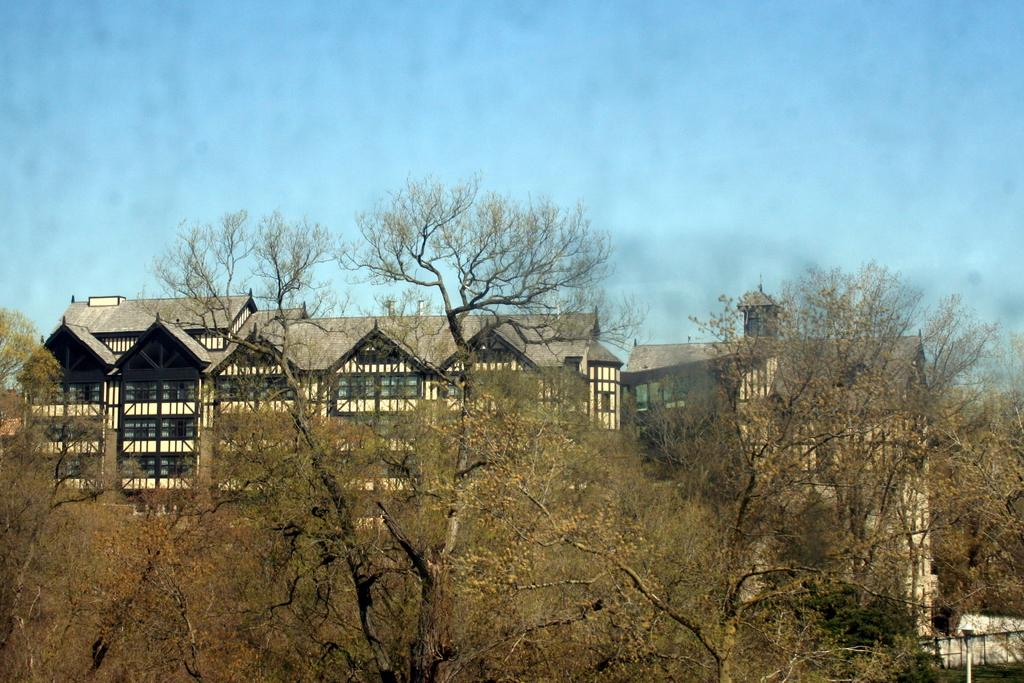What can be seen in the background of the image? There are buildings in the background of the image. What is located in the foreground of the image? There are trees in the foreground of the image. What is visible at the top of the image? The sky is visible at the top of the image. Can you tell me how many buttons are on the writer's shirt in the image? There is no writer or shirt present in the image, so it is not possible to determine the number of buttons. 